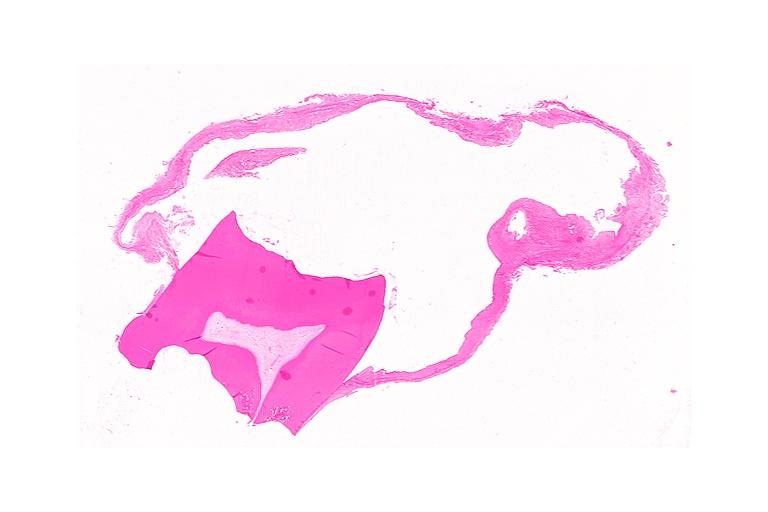does musculoskeletal show dentigerous cyst?
Answer the question using a single word or phrase. No 